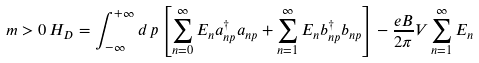Convert formula to latex. <formula><loc_0><loc_0><loc_500><loc_500>m > 0 \, H _ { D } = \int _ { - \infty } ^ { + \infty } d \, p \left [ \sum _ { n = 0 } ^ { \infty } E _ { n } a ^ { \dag } _ { n p } a _ { n p } + \sum _ { n = 1 } ^ { \infty } E _ { n } b ^ { \dag } _ { n p } b _ { n p } \right ] - \frac { e B } { 2 \pi } V \sum _ { n = 1 } ^ { \infty } E _ { n }</formula> 